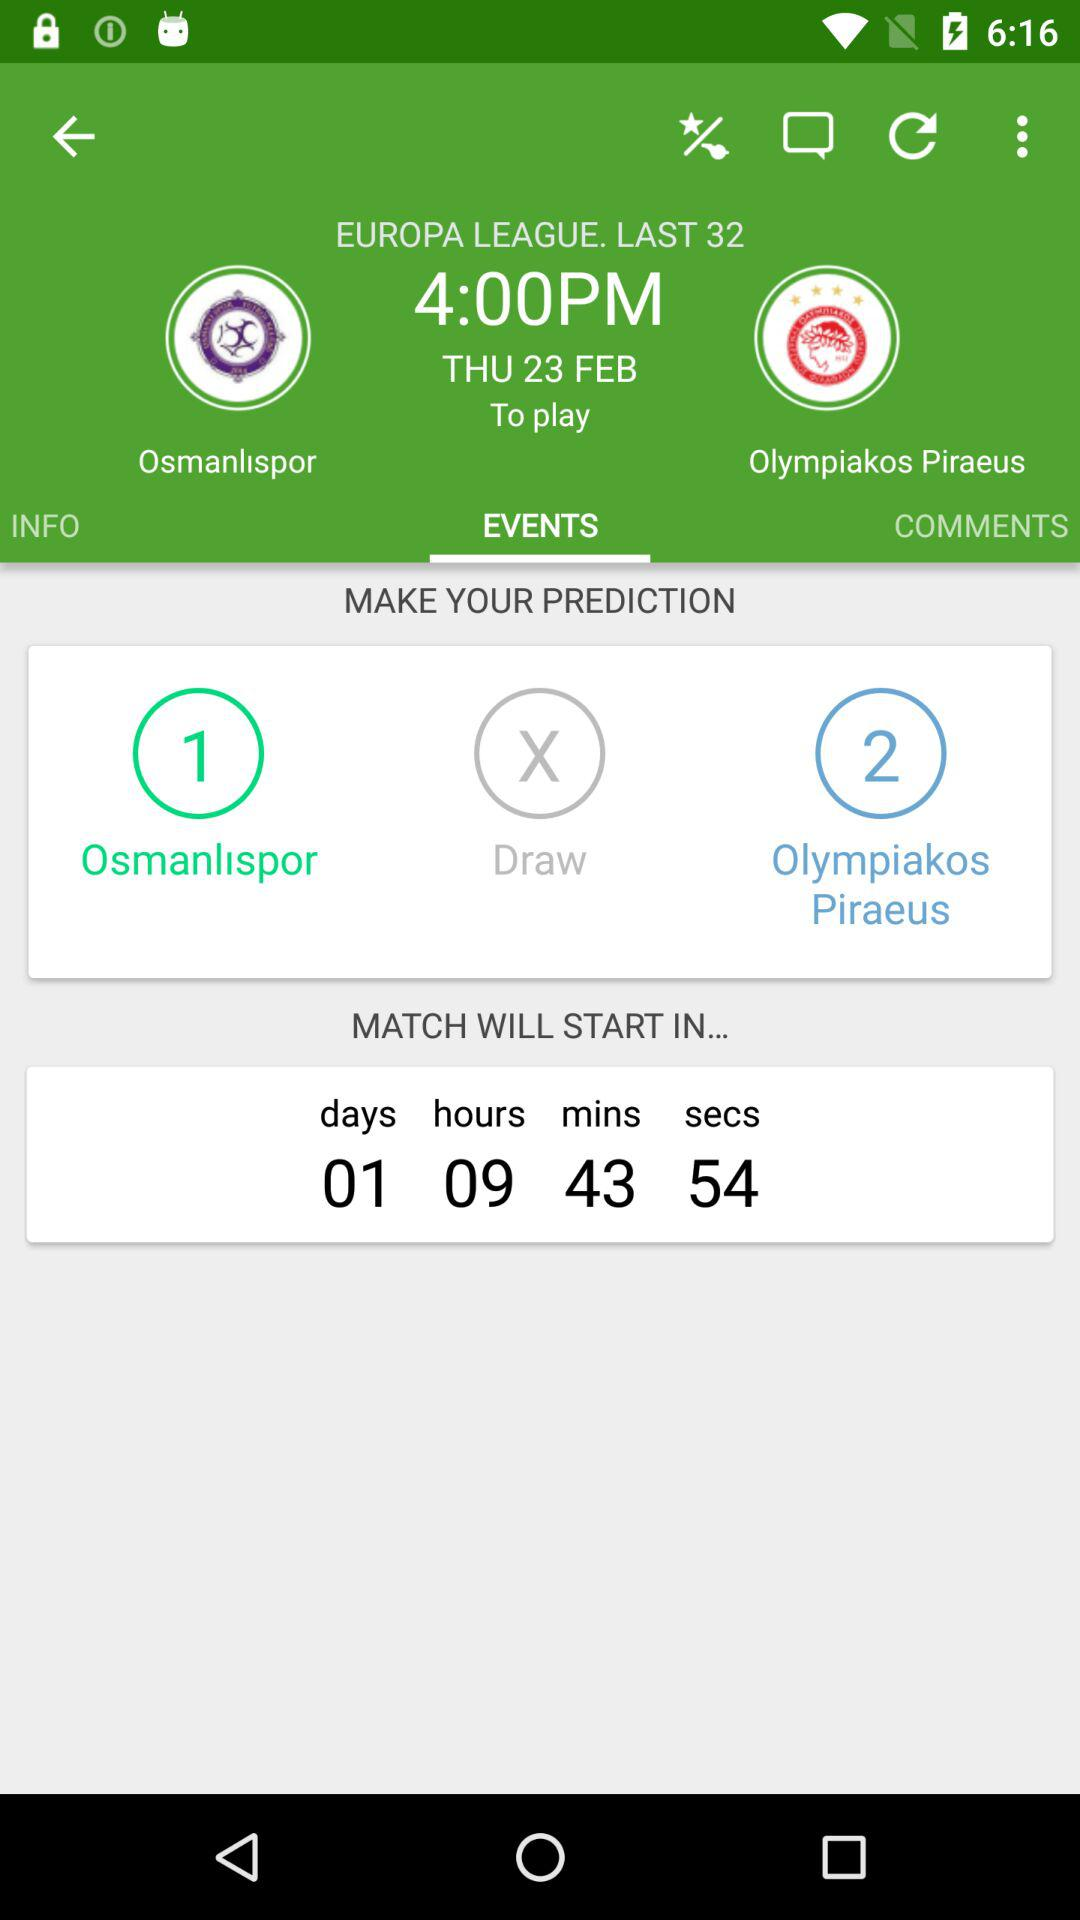What is the name of the league? The league name is "Europa". 